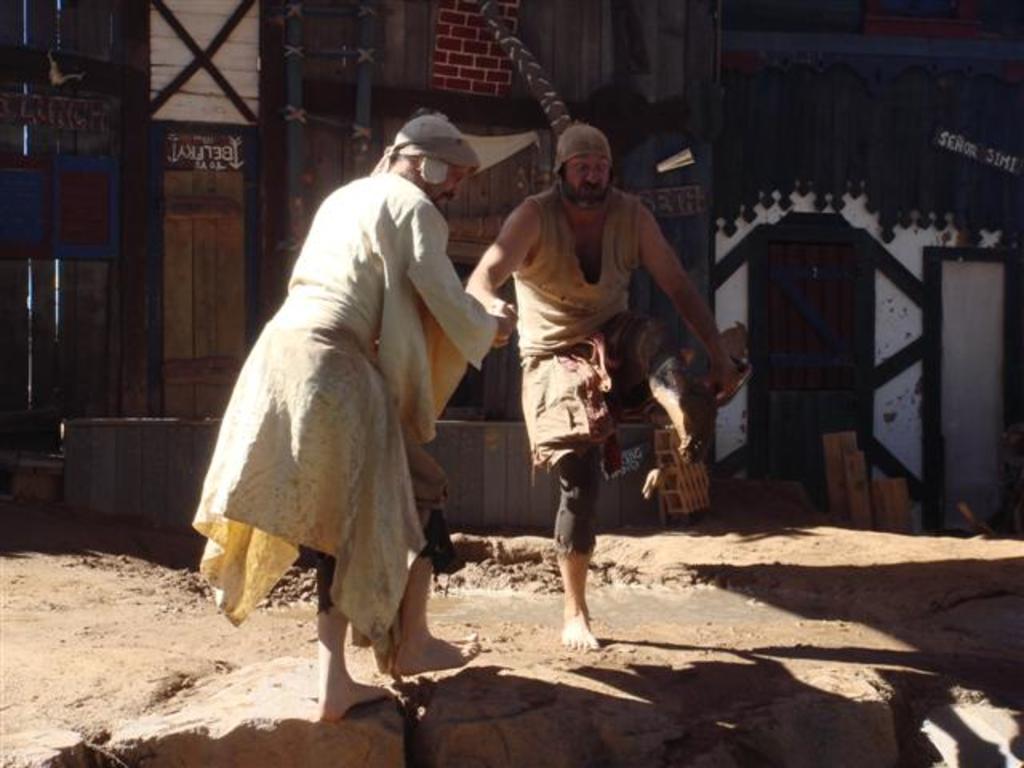Describe this image in one or two sentences. In this image in the center there are persons standing. In the background there are doors and there is a wall which is white in colour. 